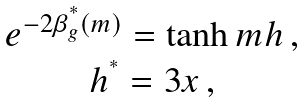<formula> <loc_0><loc_0><loc_500><loc_500>\begin{array} { c } e ^ { - 2 \beta _ { g } ^ { ^ { * } } ( m ) } = \tanh m h \, , \\ h ^ { ^ { * } } = 3 x \, , \end{array}</formula> 